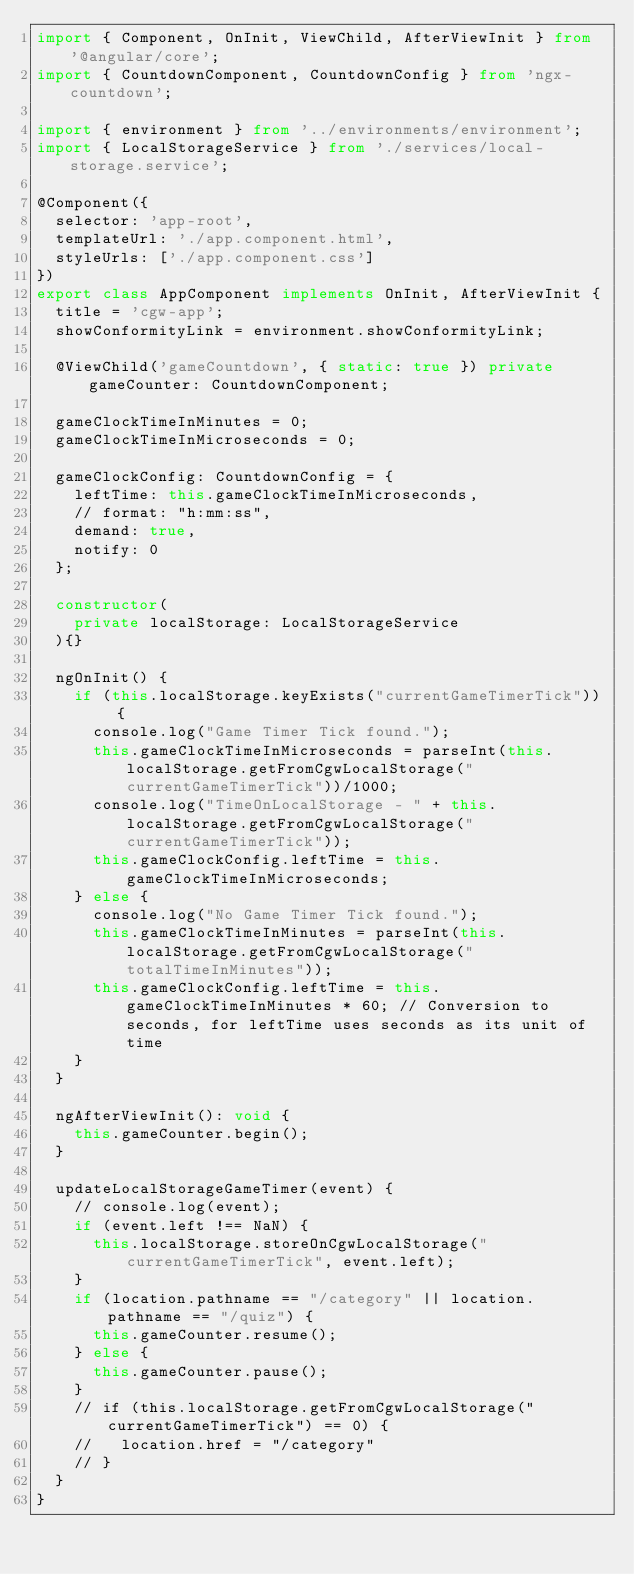<code> <loc_0><loc_0><loc_500><loc_500><_TypeScript_>import { Component, OnInit, ViewChild, AfterViewInit } from '@angular/core';
import { CountdownComponent, CountdownConfig } from 'ngx-countdown';

import { environment } from '../environments/environment';
import { LocalStorageService } from './services/local-storage.service';

@Component({
  selector: 'app-root',
  templateUrl: './app.component.html',
  styleUrls: ['./app.component.css']
})
export class AppComponent implements OnInit, AfterViewInit {
  title = 'cgw-app';
  showConformityLink = environment.showConformityLink;

  @ViewChild('gameCountdown', { static: true }) private gameCounter: CountdownComponent;

  gameClockTimeInMinutes = 0;
  gameClockTimeInMicroseconds = 0;

  gameClockConfig: CountdownConfig = {
    leftTime: this.gameClockTimeInMicroseconds,
    // format: "h:mm:ss",
    demand: true,
    notify: 0
  };

  constructor(
    private localStorage: LocalStorageService
  ){}

  ngOnInit() {
    if (this.localStorage.keyExists("currentGameTimerTick")) {
      console.log("Game Timer Tick found.");
      this.gameClockTimeInMicroseconds = parseInt(this.localStorage.getFromCgwLocalStorage("currentGameTimerTick"))/1000;
      console.log("TimeOnLocalStorage - " + this.localStorage.getFromCgwLocalStorage("currentGameTimerTick"));
      this.gameClockConfig.leftTime = this.gameClockTimeInMicroseconds;
    } else {
      console.log("No Game Timer Tick found.");
      this.gameClockTimeInMinutes = parseInt(this.localStorage.getFromCgwLocalStorage("totalTimeInMinutes"));
      this.gameClockConfig.leftTime = this.gameClockTimeInMinutes * 60; // Conversion to seconds, for leftTime uses seconds as its unit of time
    }
  }

  ngAfterViewInit(): void {
    this.gameCounter.begin();
  }

  updateLocalStorageGameTimer(event) {
    // console.log(event);
    if (event.left !== NaN) {
      this.localStorage.storeOnCgwLocalStorage("currentGameTimerTick", event.left);
    }
    if (location.pathname == "/category" || location.pathname == "/quiz") {
      this.gameCounter.resume();
    } else {
      this.gameCounter.pause();
    }
    // if (this.localStorage.getFromCgwLocalStorage("currentGameTimerTick") == 0) {
    //   location.href = "/category"
    // }
  }
}</code> 